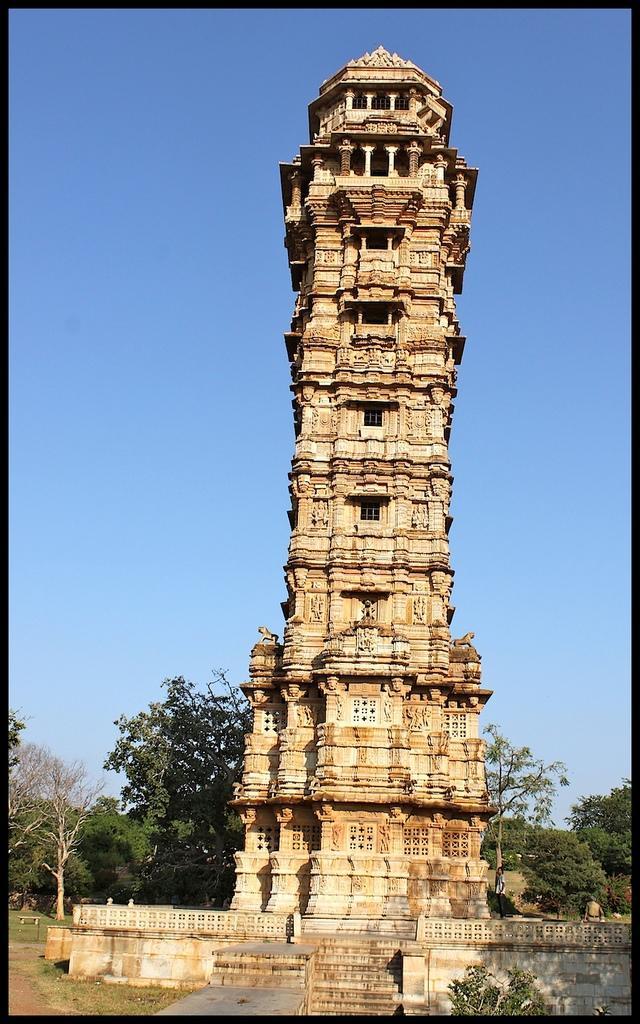In one or two sentences, can you explain what this image depicts? This picture is an edited image. In the center there is a building and we can see the green grass, trees, plants and the sky. 